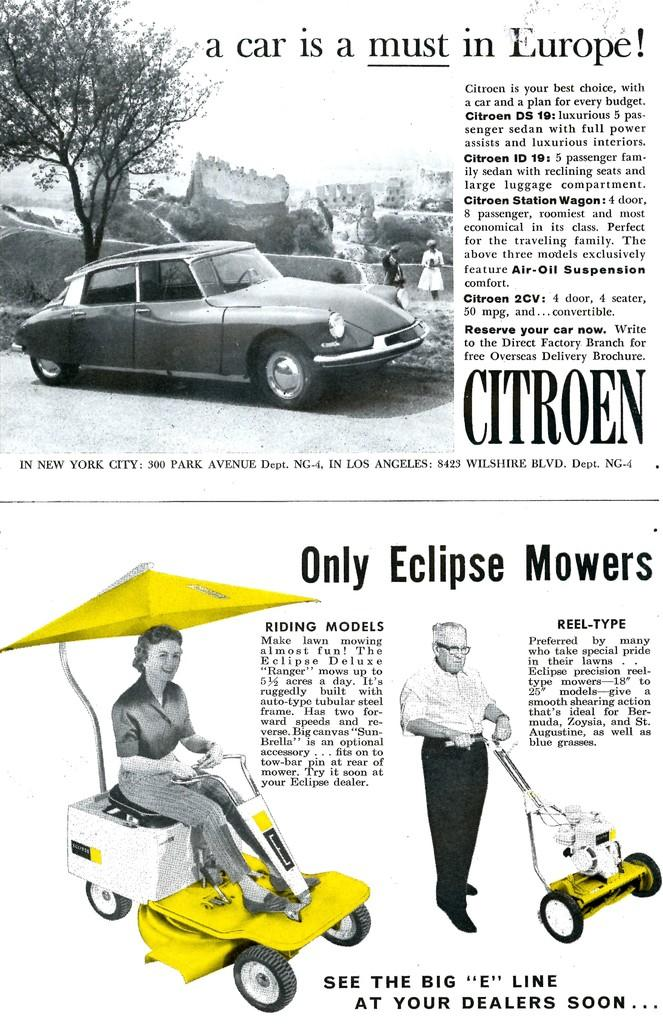What is present on the poster in the image? The poster contains images and text. Can you describe the images on the poster? The provided facts do not specify the images on the poster, so we cannot describe them. What type of furniture is visible in the image? There is no furniture present in the image. How does the poster make you feel when looking at it? The provided facts do not mention any emotions or feelings associated with the poster, so we cannot determine how it makes you feel. 